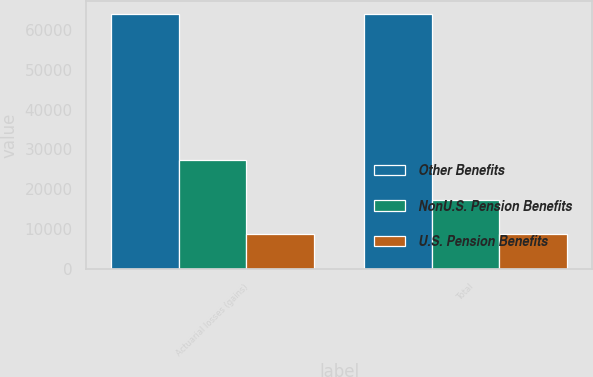Convert chart. <chart><loc_0><loc_0><loc_500><loc_500><stacked_bar_chart><ecel><fcel>Actuarial losses (gains)<fcel>Total<nl><fcel>Other Benefits<fcel>63958<fcel>63958<nl><fcel>NonU.S. Pension Benefits<fcel>27398<fcel>17366<nl><fcel>U.S. Pension Benefits<fcel>8814<fcel>8814<nl></chart> 